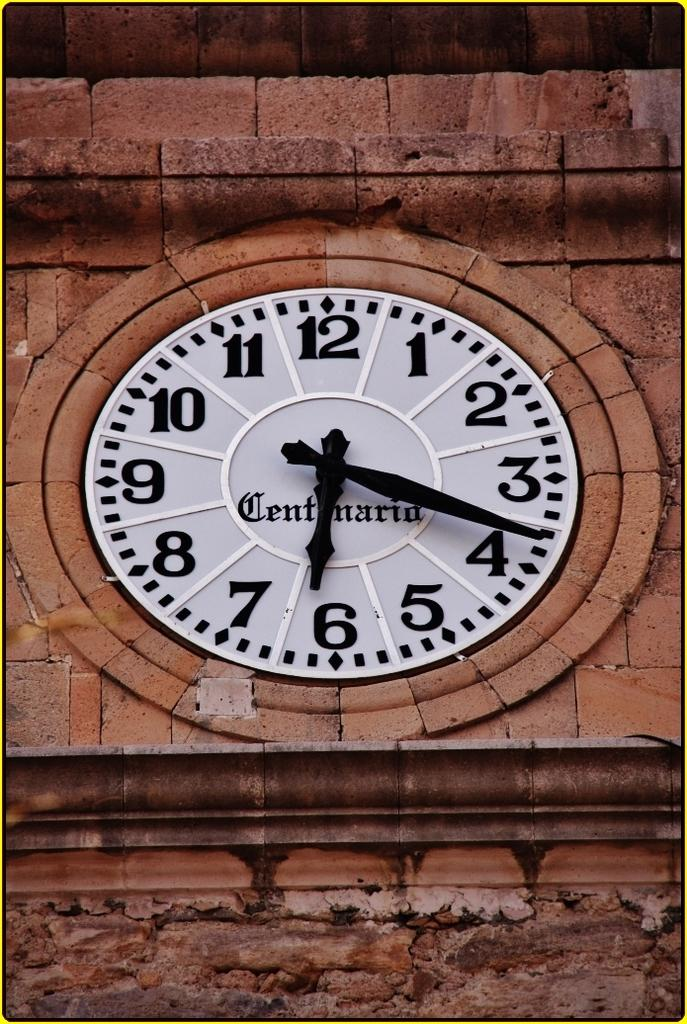<image>
Give a short and clear explanation of the subsequent image. A clock face on a building that says Centenaria on it. 